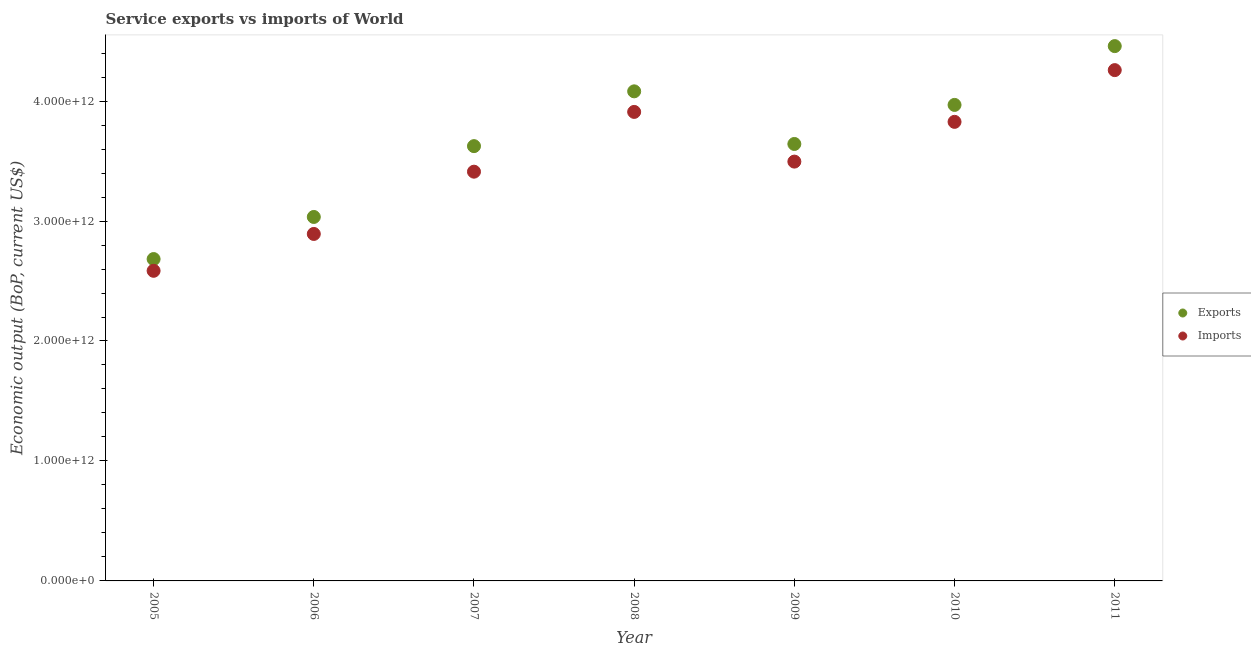What is the amount of service exports in 2006?
Give a very brief answer. 3.03e+12. Across all years, what is the maximum amount of service imports?
Make the answer very short. 4.26e+12. Across all years, what is the minimum amount of service imports?
Provide a succinct answer. 2.59e+12. In which year was the amount of service exports maximum?
Provide a short and direct response. 2011. In which year was the amount of service exports minimum?
Keep it short and to the point. 2005. What is the total amount of service exports in the graph?
Ensure brevity in your answer.  2.55e+13. What is the difference between the amount of service imports in 2006 and that in 2008?
Your answer should be compact. -1.02e+12. What is the difference between the amount of service imports in 2011 and the amount of service exports in 2009?
Ensure brevity in your answer.  6.16e+11. What is the average amount of service exports per year?
Ensure brevity in your answer.  3.64e+12. In the year 2008, what is the difference between the amount of service exports and amount of service imports?
Your answer should be compact. 1.72e+11. What is the ratio of the amount of service exports in 2005 to that in 2010?
Give a very brief answer. 0.68. What is the difference between the highest and the second highest amount of service imports?
Provide a succinct answer. 3.48e+11. What is the difference between the highest and the lowest amount of service imports?
Your response must be concise. 1.67e+12. In how many years, is the amount of service exports greater than the average amount of service exports taken over all years?
Keep it short and to the point. 4. Is the amount of service imports strictly greater than the amount of service exports over the years?
Keep it short and to the point. No. What is the difference between two consecutive major ticks on the Y-axis?
Your response must be concise. 1.00e+12. Are the values on the major ticks of Y-axis written in scientific E-notation?
Provide a succinct answer. Yes. Does the graph contain grids?
Offer a terse response. No. Where does the legend appear in the graph?
Ensure brevity in your answer.  Center right. How many legend labels are there?
Your answer should be very brief. 2. How are the legend labels stacked?
Offer a terse response. Vertical. What is the title of the graph?
Offer a very short reply. Service exports vs imports of World. Does "Forest land" appear as one of the legend labels in the graph?
Offer a very short reply. No. What is the label or title of the X-axis?
Offer a terse response. Year. What is the label or title of the Y-axis?
Ensure brevity in your answer.  Economic output (BoP, current US$). What is the Economic output (BoP, current US$) of Exports in 2005?
Provide a succinct answer. 2.68e+12. What is the Economic output (BoP, current US$) of Imports in 2005?
Provide a short and direct response. 2.59e+12. What is the Economic output (BoP, current US$) of Exports in 2006?
Your answer should be compact. 3.03e+12. What is the Economic output (BoP, current US$) of Imports in 2006?
Your answer should be compact. 2.89e+12. What is the Economic output (BoP, current US$) of Exports in 2007?
Give a very brief answer. 3.62e+12. What is the Economic output (BoP, current US$) in Imports in 2007?
Ensure brevity in your answer.  3.41e+12. What is the Economic output (BoP, current US$) in Exports in 2008?
Ensure brevity in your answer.  4.08e+12. What is the Economic output (BoP, current US$) in Imports in 2008?
Provide a short and direct response. 3.91e+12. What is the Economic output (BoP, current US$) in Exports in 2009?
Make the answer very short. 3.64e+12. What is the Economic output (BoP, current US$) in Imports in 2009?
Your response must be concise. 3.50e+12. What is the Economic output (BoP, current US$) of Exports in 2010?
Provide a short and direct response. 3.97e+12. What is the Economic output (BoP, current US$) of Imports in 2010?
Your answer should be compact. 3.83e+12. What is the Economic output (BoP, current US$) of Exports in 2011?
Provide a short and direct response. 4.46e+12. What is the Economic output (BoP, current US$) of Imports in 2011?
Your answer should be very brief. 4.26e+12. Across all years, what is the maximum Economic output (BoP, current US$) in Exports?
Make the answer very short. 4.46e+12. Across all years, what is the maximum Economic output (BoP, current US$) in Imports?
Make the answer very short. 4.26e+12. Across all years, what is the minimum Economic output (BoP, current US$) in Exports?
Provide a short and direct response. 2.68e+12. Across all years, what is the minimum Economic output (BoP, current US$) in Imports?
Provide a short and direct response. 2.59e+12. What is the total Economic output (BoP, current US$) in Exports in the graph?
Your answer should be very brief. 2.55e+13. What is the total Economic output (BoP, current US$) in Imports in the graph?
Give a very brief answer. 2.44e+13. What is the difference between the Economic output (BoP, current US$) in Exports in 2005 and that in 2006?
Offer a terse response. -3.51e+11. What is the difference between the Economic output (BoP, current US$) in Imports in 2005 and that in 2006?
Keep it short and to the point. -3.07e+11. What is the difference between the Economic output (BoP, current US$) in Exports in 2005 and that in 2007?
Ensure brevity in your answer.  -9.41e+11. What is the difference between the Economic output (BoP, current US$) in Imports in 2005 and that in 2007?
Offer a terse response. -8.26e+11. What is the difference between the Economic output (BoP, current US$) of Exports in 2005 and that in 2008?
Offer a very short reply. -1.40e+12. What is the difference between the Economic output (BoP, current US$) of Imports in 2005 and that in 2008?
Provide a succinct answer. -1.32e+12. What is the difference between the Economic output (BoP, current US$) of Exports in 2005 and that in 2009?
Your answer should be very brief. -9.59e+11. What is the difference between the Economic output (BoP, current US$) in Imports in 2005 and that in 2009?
Your answer should be compact. -9.10e+11. What is the difference between the Economic output (BoP, current US$) of Exports in 2005 and that in 2010?
Your answer should be compact. -1.28e+12. What is the difference between the Economic output (BoP, current US$) in Imports in 2005 and that in 2010?
Your answer should be very brief. -1.24e+12. What is the difference between the Economic output (BoP, current US$) in Exports in 2005 and that in 2011?
Offer a very short reply. -1.78e+12. What is the difference between the Economic output (BoP, current US$) of Imports in 2005 and that in 2011?
Offer a very short reply. -1.67e+12. What is the difference between the Economic output (BoP, current US$) in Exports in 2006 and that in 2007?
Make the answer very short. -5.90e+11. What is the difference between the Economic output (BoP, current US$) of Imports in 2006 and that in 2007?
Your answer should be very brief. -5.19e+11. What is the difference between the Economic output (BoP, current US$) of Exports in 2006 and that in 2008?
Offer a very short reply. -1.05e+12. What is the difference between the Economic output (BoP, current US$) of Imports in 2006 and that in 2008?
Offer a very short reply. -1.02e+12. What is the difference between the Economic output (BoP, current US$) in Exports in 2006 and that in 2009?
Provide a short and direct response. -6.08e+11. What is the difference between the Economic output (BoP, current US$) of Imports in 2006 and that in 2009?
Provide a succinct answer. -6.03e+11. What is the difference between the Economic output (BoP, current US$) of Exports in 2006 and that in 2010?
Your answer should be compact. -9.34e+11. What is the difference between the Economic output (BoP, current US$) in Imports in 2006 and that in 2010?
Ensure brevity in your answer.  -9.34e+11. What is the difference between the Economic output (BoP, current US$) of Exports in 2006 and that in 2011?
Keep it short and to the point. -1.42e+12. What is the difference between the Economic output (BoP, current US$) in Imports in 2006 and that in 2011?
Make the answer very short. -1.37e+12. What is the difference between the Economic output (BoP, current US$) of Exports in 2007 and that in 2008?
Make the answer very short. -4.57e+11. What is the difference between the Economic output (BoP, current US$) in Imports in 2007 and that in 2008?
Ensure brevity in your answer.  -4.98e+11. What is the difference between the Economic output (BoP, current US$) in Exports in 2007 and that in 2009?
Make the answer very short. -1.81e+1. What is the difference between the Economic output (BoP, current US$) in Imports in 2007 and that in 2009?
Offer a terse response. -8.39e+1. What is the difference between the Economic output (BoP, current US$) in Exports in 2007 and that in 2010?
Make the answer very short. -3.44e+11. What is the difference between the Economic output (BoP, current US$) in Imports in 2007 and that in 2010?
Offer a terse response. -4.15e+11. What is the difference between the Economic output (BoP, current US$) in Exports in 2007 and that in 2011?
Ensure brevity in your answer.  -8.34e+11. What is the difference between the Economic output (BoP, current US$) of Imports in 2007 and that in 2011?
Offer a very short reply. -8.47e+11. What is the difference between the Economic output (BoP, current US$) of Exports in 2008 and that in 2009?
Offer a terse response. 4.39e+11. What is the difference between the Economic output (BoP, current US$) in Imports in 2008 and that in 2009?
Make the answer very short. 4.14e+11. What is the difference between the Economic output (BoP, current US$) in Exports in 2008 and that in 2010?
Your answer should be very brief. 1.13e+11. What is the difference between the Economic output (BoP, current US$) of Imports in 2008 and that in 2010?
Offer a very short reply. 8.29e+1. What is the difference between the Economic output (BoP, current US$) in Exports in 2008 and that in 2011?
Provide a succinct answer. -3.77e+11. What is the difference between the Economic output (BoP, current US$) of Imports in 2008 and that in 2011?
Offer a very short reply. -3.48e+11. What is the difference between the Economic output (BoP, current US$) of Exports in 2009 and that in 2010?
Your answer should be very brief. -3.26e+11. What is the difference between the Economic output (BoP, current US$) in Imports in 2009 and that in 2010?
Provide a short and direct response. -3.31e+11. What is the difference between the Economic output (BoP, current US$) of Exports in 2009 and that in 2011?
Your answer should be very brief. -8.16e+11. What is the difference between the Economic output (BoP, current US$) in Imports in 2009 and that in 2011?
Your answer should be compact. -7.63e+11. What is the difference between the Economic output (BoP, current US$) in Exports in 2010 and that in 2011?
Your answer should be compact. -4.90e+11. What is the difference between the Economic output (BoP, current US$) in Imports in 2010 and that in 2011?
Keep it short and to the point. -4.31e+11. What is the difference between the Economic output (BoP, current US$) of Exports in 2005 and the Economic output (BoP, current US$) of Imports in 2006?
Offer a very short reply. -2.09e+11. What is the difference between the Economic output (BoP, current US$) in Exports in 2005 and the Economic output (BoP, current US$) in Imports in 2007?
Your response must be concise. -7.28e+11. What is the difference between the Economic output (BoP, current US$) in Exports in 2005 and the Economic output (BoP, current US$) in Imports in 2008?
Provide a succinct answer. -1.23e+12. What is the difference between the Economic output (BoP, current US$) in Exports in 2005 and the Economic output (BoP, current US$) in Imports in 2009?
Your answer should be compact. -8.12e+11. What is the difference between the Economic output (BoP, current US$) in Exports in 2005 and the Economic output (BoP, current US$) in Imports in 2010?
Offer a very short reply. -1.14e+12. What is the difference between the Economic output (BoP, current US$) in Exports in 2005 and the Economic output (BoP, current US$) in Imports in 2011?
Make the answer very short. -1.57e+12. What is the difference between the Economic output (BoP, current US$) of Exports in 2006 and the Economic output (BoP, current US$) of Imports in 2007?
Keep it short and to the point. -3.77e+11. What is the difference between the Economic output (BoP, current US$) of Exports in 2006 and the Economic output (BoP, current US$) of Imports in 2008?
Offer a terse response. -8.76e+11. What is the difference between the Economic output (BoP, current US$) of Exports in 2006 and the Economic output (BoP, current US$) of Imports in 2009?
Provide a succinct answer. -4.61e+11. What is the difference between the Economic output (BoP, current US$) of Exports in 2006 and the Economic output (BoP, current US$) of Imports in 2010?
Provide a short and direct response. -7.93e+11. What is the difference between the Economic output (BoP, current US$) of Exports in 2006 and the Economic output (BoP, current US$) of Imports in 2011?
Your response must be concise. -1.22e+12. What is the difference between the Economic output (BoP, current US$) in Exports in 2007 and the Economic output (BoP, current US$) in Imports in 2008?
Ensure brevity in your answer.  -2.85e+11. What is the difference between the Economic output (BoP, current US$) of Exports in 2007 and the Economic output (BoP, current US$) of Imports in 2009?
Make the answer very short. 1.29e+11. What is the difference between the Economic output (BoP, current US$) in Exports in 2007 and the Economic output (BoP, current US$) in Imports in 2010?
Make the answer very short. -2.02e+11. What is the difference between the Economic output (BoP, current US$) of Exports in 2007 and the Economic output (BoP, current US$) of Imports in 2011?
Give a very brief answer. -6.34e+11. What is the difference between the Economic output (BoP, current US$) in Exports in 2008 and the Economic output (BoP, current US$) in Imports in 2009?
Offer a terse response. 5.86e+11. What is the difference between the Economic output (BoP, current US$) of Exports in 2008 and the Economic output (BoP, current US$) of Imports in 2010?
Make the answer very short. 2.54e+11. What is the difference between the Economic output (BoP, current US$) in Exports in 2008 and the Economic output (BoP, current US$) in Imports in 2011?
Your answer should be compact. -1.77e+11. What is the difference between the Economic output (BoP, current US$) in Exports in 2009 and the Economic output (BoP, current US$) in Imports in 2010?
Provide a short and direct response. -1.84e+11. What is the difference between the Economic output (BoP, current US$) in Exports in 2009 and the Economic output (BoP, current US$) in Imports in 2011?
Make the answer very short. -6.16e+11. What is the difference between the Economic output (BoP, current US$) of Exports in 2010 and the Economic output (BoP, current US$) of Imports in 2011?
Ensure brevity in your answer.  -2.90e+11. What is the average Economic output (BoP, current US$) of Exports per year?
Offer a very short reply. 3.64e+12. What is the average Economic output (BoP, current US$) of Imports per year?
Make the answer very short. 3.48e+12. In the year 2005, what is the difference between the Economic output (BoP, current US$) of Exports and Economic output (BoP, current US$) of Imports?
Keep it short and to the point. 9.80e+1. In the year 2006, what is the difference between the Economic output (BoP, current US$) of Exports and Economic output (BoP, current US$) of Imports?
Give a very brief answer. 1.42e+11. In the year 2007, what is the difference between the Economic output (BoP, current US$) of Exports and Economic output (BoP, current US$) of Imports?
Ensure brevity in your answer.  2.13e+11. In the year 2008, what is the difference between the Economic output (BoP, current US$) in Exports and Economic output (BoP, current US$) in Imports?
Your answer should be very brief. 1.72e+11. In the year 2009, what is the difference between the Economic output (BoP, current US$) in Exports and Economic output (BoP, current US$) in Imports?
Ensure brevity in your answer.  1.47e+11. In the year 2010, what is the difference between the Economic output (BoP, current US$) in Exports and Economic output (BoP, current US$) in Imports?
Offer a terse response. 1.41e+11. In the year 2011, what is the difference between the Economic output (BoP, current US$) of Exports and Economic output (BoP, current US$) of Imports?
Offer a terse response. 2.00e+11. What is the ratio of the Economic output (BoP, current US$) in Exports in 2005 to that in 2006?
Your answer should be very brief. 0.88. What is the ratio of the Economic output (BoP, current US$) of Imports in 2005 to that in 2006?
Provide a short and direct response. 0.89. What is the ratio of the Economic output (BoP, current US$) in Exports in 2005 to that in 2007?
Provide a succinct answer. 0.74. What is the ratio of the Economic output (BoP, current US$) in Imports in 2005 to that in 2007?
Provide a short and direct response. 0.76. What is the ratio of the Economic output (BoP, current US$) of Exports in 2005 to that in 2008?
Ensure brevity in your answer.  0.66. What is the ratio of the Economic output (BoP, current US$) of Imports in 2005 to that in 2008?
Provide a short and direct response. 0.66. What is the ratio of the Economic output (BoP, current US$) of Exports in 2005 to that in 2009?
Keep it short and to the point. 0.74. What is the ratio of the Economic output (BoP, current US$) of Imports in 2005 to that in 2009?
Give a very brief answer. 0.74. What is the ratio of the Economic output (BoP, current US$) of Exports in 2005 to that in 2010?
Make the answer very short. 0.68. What is the ratio of the Economic output (BoP, current US$) in Imports in 2005 to that in 2010?
Your response must be concise. 0.68. What is the ratio of the Economic output (BoP, current US$) in Exports in 2005 to that in 2011?
Ensure brevity in your answer.  0.6. What is the ratio of the Economic output (BoP, current US$) in Imports in 2005 to that in 2011?
Make the answer very short. 0.61. What is the ratio of the Economic output (BoP, current US$) in Exports in 2006 to that in 2007?
Keep it short and to the point. 0.84. What is the ratio of the Economic output (BoP, current US$) of Imports in 2006 to that in 2007?
Your response must be concise. 0.85. What is the ratio of the Economic output (BoP, current US$) in Exports in 2006 to that in 2008?
Offer a very short reply. 0.74. What is the ratio of the Economic output (BoP, current US$) in Imports in 2006 to that in 2008?
Give a very brief answer. 0.74. What is the ratio of the Economic output (BoP, current US$) of Exports in 2006 to that in 2009?
Your answer should be compact. 0.83. What is the ratio of the Economic output (BoP, current US$) in Imports in 2006 to that in 2009?
Offer a terse response. 0.83. What is the ratio of the Economic output (BoP, current US$) in Exports in 2006 to that in 2010?
Make the answer very short. 0.76. What is the ratio of the Economic output (BoP, current US$) in Imports in 2006 to that in 2010?
Your answer should be very brief. 0.76. What is the ratio of the Economic output (BoP, current US$) of Exports in 2006 to that in 2011?
Offer a very short reply. 0.68. What is the ratio of the Economic output (BoP, current US$) of Imports in 2006 to that in 2011?
Your answer should be very brief. 0.68. What is the ratio of the Economic output (BoP, current US$) in Exports in 2007 to that in 2008?
Offer a terse response. 0.89. What is the ratio of the Economic output (BoP, current US$) in Imports in 2007 to that in 2008?
Your answer should be compact. 0.87. What is the ratio of the Economic output (BoP, current US$) of Exports in 2007 to that in 2009?
Your answer should be compact. 0.99. What is the ratio of the Economic output (BoP, current US$) in Exports in 2007 to that in 2010?
Offer a terse response. 0.91. What is the ratio of the Economic output (BoP, current US$) of Imports in 2007 to that in 2010?
Provide a succinct answer. 0.89. What is the ratio of the Economic output (BoP, current US$) in Exports in 2007 to that in 2011?
Provide a short and direct response. 0.81. What is the ratio of the Economic output (BoP, current US$) of Imports in 2007 to that in 2011?
Keep it short and to the point. 0.8. What is the ratio of the Economic output (BoP, current US$) of Exports in 2008 to that in 2009?
Your response must be concise. 1.12. What is the ratio of the Economic output (BoP, current US$) in Imports in 2008 to that in 2009?
Your answer should be very brief. 1.12. What is the ratio of the Economic output (BoP, current US$) of Exports in 2008 to that in 2010?
Offer a terse response. 1.03. What is the ratio of the Economic output (BoP, current US$) of Imports in 2008 to that in 2010?
Make the answer very short. 1.02. What is the ratio of the Economic output (BoP, current US$) of Exports in 2008 to that in 2011?
Make the answer very short. 0.92. What is the ratio of the Economic output (BoP, current US$) of Imports in 2008 to that in 2011?
Provide a short and direct response. 0.92. What is the ratio of the Economic output (BoP, current US$) of Exports in 2009 to that in 2010?
Your response must be concise. 0.92. What is the ratio of the Economic output (BoP, current US$) of Imports in 2009 to that in 2010?
Offer a very short reply. 0.91. What is the ratio of the Economic output (BoP, current US$) in Exports in 2009 to that in 2011?
Your answer should be compact. 0.82. What is the ratio of the Economic output (BoP, current US$) in Imports in 2009 to that in 2011?
Your answer should be compact. 0.82. What is the ratio of the Economic output (BoP, current US$) in Exports in 2010 to that in 2011?
Offer a very short reply. 0.89. What is the ratio of the Economic output (BoP, current US$) in Imports in 2010 to that in 2011?
Keep it short and to the point. 0.9. What is the difference between the highest and the second highest Economic output (BoP, current US$) in Exports?
Offer a terse response. 3.77e+11. What is the difference between the highest and the second highest Economic output (BoP, current US$) of Imports?
Your response must be concise. 3.48e+11. What is the difference between the highest and the lowest Economic output (BoP, current US$) in Exports?
Offer a terse response. 1.78e+12. What is the difference between the highest and the lowest Economic output (BoP, current US$) in Imports?
Your response must be concise. 1.67e+12. 